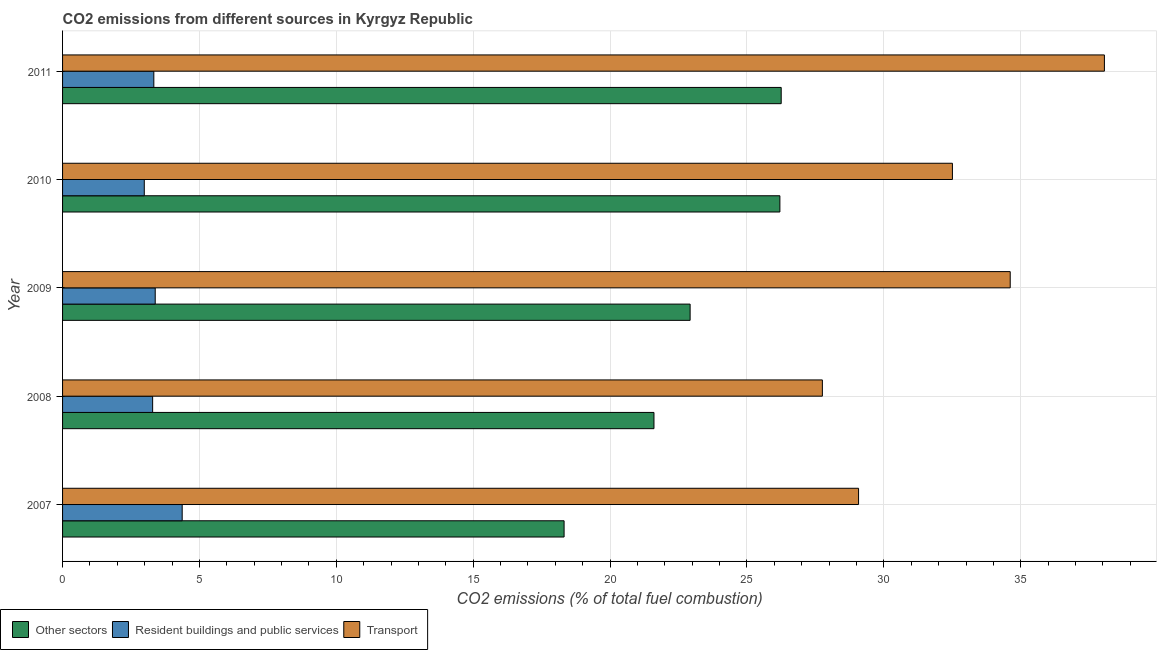Are the number of bars per tick equal to the number of legend labels?
Offer a terse response. Yes. What is the label of the 5th group of bars from the top?
Give a very brief answer. 2007. What is the percentage of co2 emissions from resident buildings and public services in 2009?
Ensure brevity in your answer.  3.38. Across all years, what is the maximum percentage of co2 emissions from transport?
Give a very brief answer. 38.06. Across all years, what is the minimum percentage of co2 emissions from other sectors?
Ensure brevity in your answer.  18.32. In which year was the percentage of co2 emissions from other sectors maximum?
Provide a succinct answer. 2011. What is the total percentage of co2 emissions from resident buildings and public services in the graph?
Provide a succinct answer. 17.36. What is the difference between the percentage of co2 emissions from resident buildings and public services in 2009 and that in 2010?
Your response must be concise. 0.4. What is the difference between the percentage of co2 emissions from other sectors in 2007 and the percentage of co2 emissions from transport in 2011?
Keep it short and to the point. -19.74. What is the average percentage of co2 emissions from transport per year?
Your response must be concise. 32.4. In the year 2007, what is the difference between the percentage of co2 emissions from transport and percentage of co2 emissions from other sectors?
Your response must be concise. 10.76. In how many years, is the percentage of co2 emissions from resident buildings and public services greater than 7 %?
Your answer should be very brief. 0. What is the ratio of the percentage of co2 emissions from resident buildings and public services in 2007 to that in 2011?
Keep it short and to the point. 1.31. Is the percentage of co2 emissions from other sectors in 2009 less than that in 2010?
Offer a terse response. Yes. What is the difference between the highest and the second highest percentage of co2 emissions from other sectors?
Offer a very short reply. 0.05. What is the difference between the highest and the lowest percentage of co2 emissions from other sectors?
Give a very brief answer. 7.93. In how many years, is the percentage of co2 emissions from resident buildings and public services greater than the average percentage of co2 emissions from resident buildings and public services taken over all years?
Offer a very short reply. 1. Is the sum of the percentage of co2 emissions from resident buildings and public services in 2007 and 2008 greater than the maximum percentage of co2 emissions from transport across all years?
Your answer should be very brief. No. What does the 1st bar from the top in 2010 represents?
Your answer should be compact. Transport. What does the 3rd bar from the bottom in 2009 represents?
Ensure brevity in your answer.  Transport. How many years are there in the graph?
Your response must be concise. 5. Are the values on the major ticks of X-axis written in scientific E-notation?
Keep it short and to the point. No. Does the graph contain any zero values?
Offer a very short reply. No. Where does the legend appear in the graph?
Provide a short and direct response. Bottom left. What is the title of the graph?
Keep it short and to the point. CO2 emissions from different sources in Kyrgyz Republic. Does "Social Protection" appear as one of the legend labels in the graph?
Provide a short and direct response. No. What is the label or title of the X-axis?
Your answer should be compact. CO2 emissions (% of total fuel combustion). What is the CO2 emissions (% of total fuel combustion) in Other sectors in 2007?
Your answer should be compact. 18.32. What is the CO2 emissions (% of total fuel combustion) in Resident buildings and public services in 2007?
Keep it short and to the point. 4.37. What is the CO2 emissions (% of total fuel combustion) of Transport in 2007?
Provide a succinct answer. 29.08. What is the CO2 emissions (% of total fuel combustion) in Other sectors in 2008?
Offer a very short reply. 21.6. What is the CO2 emissions (% of total fuel combustion) of Resident buildings and public services in 2008?
Keep it short and to the point. 3.29. What is the CO2 emissions (% of total fuel combustion) of Transport in 2008?
Your response must be concise. 27.75. What is the CO2 emissions (% of total fuel combustion) of Other sectors in 2009?
Provide a succinct answer. 22.92. What is the CO2 emissions (% of total fuel combustion) in Resident buildings and public services in 2009?
Provide a short and direct response. 3.38. What is the CO2 emissions (% of total fuel combustion) in Transport in 2009?
Your answer should be compact. 34.62. What is the CO2 emissions (% of total fuel combustion) of Other sectors in 2010?
Give a very brief answer. 26.2. What is the CO2 emissions (% of total fuel combustion) in Resident buildings and public services in 2010?
Offer a terse response. 2.99. What is the CO2 emissions (% of total fuel combustion) in Transport in 2010?
Provide a short and direct response. 32.5. What is the CO2 emissions (% of total fuel combustion) in Other sectors in 2011?
Provide a short and direct response. 26.25. What is the CO2 emissions (% of total fuel combustion) in Resident buildings and public services in 2011?
Offer a terse response. 3.33. What is the CO2 emissions (% of total fuel combustion) in Transport in 2011?
Provide a short and direct response. 38.06. Across all years, what is the maximum CO2 emissions (% of total fuel combustion) in Other sectors?
Your response must be concise. 26.25. Across all years, what is the maximum CO2 emissions (% of total fuel combustion) in Resident buildings and public services?
Keep it short and to the point. 4.37. Across all years, what is the maximum CO2 emissions (% of total fuel combustion) in Transport?
Give a very brief answer. 38.06. Across all years, what is the minimum CO2 emissions (% of total fuel combustion) in Other sectors?
Provide a succinct answer. 18.32. Across all years, what is the minimum CO2 emissions (% of total fuel combustion) of Resident buildings and public services?
Offer a terse response. 2.99. Across all years, what is the minimum CO2 emissions (% of total fuel combustion) in Transport?
Make the answer very short. 27.75. What is the total CO2 emissions (% of total fuel combustion) in Other sectors in the graph?
Your answer should be very brief. 115.3. What is the total CO2 emissions (% of total fuel combustion) of Resident buildings and public services in the graph?
Your answer should be very brief. 17.36. What is the total CO2 emissions (% of total fuel combustion) in Transport in the graph?
Ensure brevity in your answer.  162. What is the difference between the CO2 emissions (% of total fuel combustion) in Other sectors in 2007 and that in 2008?
Offer a terse response. -3.28. What is the difference between the CO2 emissions (% of total fuel combustion) of Resident buildings and public services in 2007 and that in 2008?
Your answer should be very brief. 1.08. What is the difference between the CO2 emissions (% of total fuel combustion) of Transport in 2007 and that in 2008?
Provide a short and direct response. 1.32. What is the difference between the CO2 emissions (% of total fuel combustion) in Other sectors in 2007 and that in 2009?
Your answer should be very brief. -4.6. What is the difference between the CO2 emissions (% of total fuel combustion) in Resident buildings and public services in 2007 and that in 2009?
Provide a short and direct response. 0.99. What is the difference between the CO2 emissions (% of total fuel combustion) of Transport in 2007 and that in 2009?
Your response must be concise. -5.54. What is the difference between the CO2 emissions (% of total fuel combustion) of Other sectors in 2007 and that in 2010?
Give a very brief answer. -7.88. What is the difference between the CO2 emissions (% of total fuel combustion) in Resident buildings and public services in 2007 and that in 2010?
Your answer should be compact. 1.38. What is the difference between the CO2 emissions (% of total fuel combustion) of Transport in 2007 and that in 2010?
Your answer should be compact. -3.43. What is the difference between the CO2 emissions (% of total fuel combustion) in Other sectors in 2007 and that in 2011?
Make the answer very short. -7.93. What is the difference between the CO2 emissions (% of total fuel combustion) of Resident buildings and public services in 2007 and that in 2011?
Ensure brevity in your answer.  1.04. What is the difference between the CO2 emissions (% of total fuel combustion) of Transport in 2007 and that in 2011?
Make the answer very short. -8.98. What is the difference between the CO2 emissions (% of total fuel combustion) in Other sectors in 2008 and that in 2009?
Make the answer very short. -1.32. What is the difference between the CO2 emissions (% of total fuel combustion) of Resident buildings and public services in 2008 and that in 2009?
Your answer should be compact. -0.09. What is the difference between the CO2 emissions (% of total fuel combustion) in Transport in 2008 and that in 2009?
Give a very brief answer. -6.86. What is the difference between the CO2 emissions (% of total fuel combustion) in Resident buildings and public services in 2008 and that in 2010?
Offer a terse response. 0.31. What is the difference between the CO2 emissions (% of total fuel combustion) of Transport in 2008 and that in 2010?
Your answer should be very brief. -4.75. What is the difference between the CO2 emissions (% of total fuel combustion) in Other sectors in 2008 and that in 2011?
Provide a succinct answer. -4.65. What is the difference between the CO2 emissions (% of total fuel combustion) of Resident buildings and public services in 2008 and that in 2011?
Your answer should be very brief. -0.04. What is the difference between the CO2 emissions (% of total fuel combustion) in Transport in 2008 and that in 2011?
Ensure brevity in your answer.  -10.3. What is the difference between the CO2 emissions (% of total fuel combustion) in Other sectors in 2009 and that in 2010?
Your answer should be compact. -3.28. What is the difference between the CO2 emissions (% of total fuel combustion) in Resident buildings and public services in 2009 and that in 2010?
Provide a short and direct response. 0.4. What is the difference between the CO2 emissions (% of total fuel combustion) in Transport in 2009 and that in 2010?
Make the answer very short. 2.11. What is the difference between the CO2 emissions (% of total fuel combustion) of Other sectors in 2009 and that in 2011?
Your response must be concise. -3.33. What is the difference between the CO2 emissions (% of total fuel combustion) in Resident buildings and public services in 2009 and that in 2011?
Provide a short and direct response. 0.05. What is the difference between the CO2 emissions (% of total fuel combustion) in Transport in 2009 and that in 2011?
Provide a short and direct response. -3.44. What is the difference between the CO2 emissions (% of total fuel combustion) of Other sectors in 2010 and that in 2011?
Your answer should be very brief. -0.05. What is the difference between the CO2 emissions (% of total fuel combustion) in Resident buildings and public services in 2010 and that in 2011?
Keep it short and to the point. -0.35. What is the difference between the CO2 emissions (% of total fuel combustion) of Transport in 2010 and that in 2011?
Offer a very short reply. -5.55. What is the difference between the CO2 emissions (% of total fuel combustion) of Other sectors in 2007 and the CO2 emissions (% of total fuel combustion) of Resident buildings and public services in 2008?
Keep it short and to the point. 15.03. What is the difference between the CO2 emissions (% of total fuel combustion) in Other sectors in 2007 and the CO2 emissions (% of total fuel combustion) in Transport in 2008?
Keep it short and to the point. -9.43. What is the difference between the CO2 emissions (% of total fuel combustion) of Resident buildings and public services in 2007 and the CO2 emissions (% of total fuel combustion) of Transport in 2008?
Ensure brevity in your answer.  -23.38. What is the difference between the CO2 emissions (% of total fuel combustion) of Other sectors in 2007 and the CO2 emissions (% of total fuel combustion) of Resident buildings and public services in 2009?
Give a very brief answer. 14.93. What is the difference between the CO2 emissions (% of total fuel combustion) of Other sectors in 2007 and the CO2 emissions (% of total fuel combustion) of Transport in 2009?
Provide a succinct answer. -16.3. What is the difference between the CO2 emissions (% of total fuel combustion) of Resident buildings and public services in 2007 and the CO2 emissions (% of total fuel combustion) of Transport in 2009?
Keep it short and to the point. -30.25. What is the difference between the CO2 emissions (% of total fuel combustion) in Other sectors in 2007 and the CO2 emissions (% of total fuel combustion) in Resident buildings and public services in 2010?
Give a very brief answer. 15.33. What is the difference between the CO2 emissions (% of total fuel combustion) in Other sectors in 2007 and the CO2 emissions (% of total fuel combustion) in Transport in 2010?
Your answer should be compact. -14.18. What is the difference between the CO2 emissions (% of total fuel combustion) in Resident buildings and public services in 2007 and the CO2 emissions (% of total fuel combustion) in Transport in 2010?
Offer a terse response. -28.13. What is the difference between the CO2 emissions (% of total fuel combustion) in Other sectors in 2007 and the CO2 emissions (% of total fuel combustion) in Resident buildings and public services in 2011?
Keep it short and to the point. 14.99. What is the difference between the CO2 emissions (% of total fuel combustion) in Other sectors in 2007 and the CO2 emissions (% of total fuel combustion) in Transport in 2011?
Offer a terse response. -19.74. What is the difference between the CO2 emissions (% of total fuel combustion) of Resident buildings and public services in 2007 and the CO2 emissions (% of total fuel combustion) of Transport in 2011?
Offer a terse response. -33.69. What is the difference between the CO2 emissions (% of total fuel combustion) of Other sectors in 2008 and the CO2 emissions (% of total fuel combustion) of Resident buildings and public services in 2009?
Offer a very short reply. 18.22. What is the difference between the CO2 emissions (% of total fuel combustion) in Other sectors in 2008 and the CO2 emissions (% of total fuel combustion) in Transport in 2009?
Offer a very short reply. -13.01. What is the difference between the CO2 emissions (% of total fuel combustion) in Resident buildings and public services in 2008 and the CO2 emissions (% of total fuel combustion) in Transport in 2009?
Ensure brevity in your answer.  -31.32. What is the difference between the CO2 emissions (% of total fuel combustion) in Other sectors in 2008 and the CO2 emissions (% of total fuel combustion) in Resident buildings and public services in 2010?
Your answer should be compact. 18.62. What is the difference between the CO2 emissions (% of total fuel combustion) of Other sectors in 2008 and the CO2 emissions (% of total fuel combustion) of Transport in 2010?
Your response must be concise. -10.9. What is the difference between the CO2 emissions (% of total fuel combustion) of Resident buildings and public services in 2008 and the CO2 emissions (% of total fuel combustion) of Transport in 2010?
Keep it short and to the point. -29.21. What is the difference between the CO2 emissions (% of total fuel combustion) in Other sectors in 2008 and the CO2 emissions (% of total fuel combustion) in Resident buildings and public services in 2011?
Keep it short and to the point. 18.27. What is the difference between the CO2 emissions (% of total fuel combustion) of Other sectors in 2008 and the CO2 emissions (% of total fuel combustion) of Transport in 2011?
Provide a short and direct response. -16.45. What is the difference between the CO2 emissions (% of total fuel combustion) in Resident buildings and public services in 2008 and the CO2 emissions (% of total fuel combustion) in Transport in 2011?
Provide a succinct answer. -34.77. What is the difference between the CO2 emissions (% of total fuel combustion) in Other sectors in 2009 and the CO2 emissions (% of total fuel combustion) in Resident buildings and public services in 2010?
Your response must be concise. 19.94. What is the difference between the CO2 emissions (% of total fuel combustion) in Other sectors in 2009 and the CO2 emissions (% of total fuel combustion) in Transport in 2010?
Ensure brevity in your answer.  -9.58. What is the difference between the CO2 emissions (% of total fuel combustion) of Resident buildings and public services in 2009 and the CO2 emissions (% of total fuel combustion) of Transport in 2010?
Provide a short and direct response. -29.12. What is the difference between the CO2 emissions (% of total fuel combustion) in Other sectors in 2009 and the CO2 emissions (% of total fuel combustion) in Resident buildings and public services in 2011?
Your response must be concise. 19.59. What is the difference between the CO2 emissions (% of total fuel combustion) in Other sectors in 2009 and the CO2 emissions (% of total fuel combustion) in Transport in 2011?
Provide a short and direct response. -15.13. What is the difference between the CO2 emissions (% of total fuel combustion) in Resident buildings and public services in 2009 and the CO2 emissions (% of total fuel combustion) in Transport in 2011?
Provide a succinct answer. -34.67. What is the difference between the CO2 emissions (% of total fuel combustion) of Other sectors in 2010 and the CO2 emissions (% of total fuel combustion) of Resident buildings and public services in 2011?
Your response must be concise. 22.87. What is the difference between the CO2 emissions (% of total fuel combustion) in Other sectors in 2010 and the CO2 emissions (% of total fuel combustion) in Transport in 2011?
Your answer should be very brief. -11.85. What is the difference between the CO2 emissions (% of total fuel combustion) of Resident buildings and public services in 2010 and the CO2 emissions (% of total fuel combustion) of Transport in 2011?
Make the answer very short. -35.07. What is the average CO2 emissions (% of total fuel combustion) of Other sectors per year?
Make the answer very short. 23.06. What is the average CO2 emissions (% of total fuel combustion) of Resident buildings and public services per year?
Offer a terse response. 3.47. What is the average CO2 emissions (% of total fuel combustion) in Transport per year?
Ensure brevity in your answer.  32.4. In the year 2007, what is the difference between the CO2 emissions (% of total fuel combustion) of Other sectors and CO2 emissions (% of total fuel combustion) of Resident buildings and public services?
Provide a short and direct response. 13.95. In the year 2007, what is the difference between the CO2 emissions (% of total fuel combustion) in Other sectors and CO2 emissions (% of total fuel combustion) in Transport?
Provide a succinct answer. -10.76. In the year 2007, what is the difference between the CO2 emissions (% of total fuel combustion) of Resident buildings and public services and CO2 emissions (% of total fuel combustion) of Transport?
Keep it short and to the point. -24.71. In the year 2008, what is the difference between the CO2 emissions (% of total fuel combustion) in Other sectors and CO2 emissions (% of total fuel combustion) in Resident buildings and public services?
Your answer should be very brief. 18.31. In the year 2008, what is the difference between the CO2 emissions (% of total fuel combustion) of Other sectors and CO2 emissions (% of total fuel combustion) of Transport?
Ensure brevity in your answer.  -6.15. In the year 2008, what is the difference between the CO2 emissions (% of total fuel combustion) in Resident buildings and public services and CO2 emissions (% of total fuel combustion) in Transport?
Give a very brief answer. -24.46. In the year 2009, what is the difference between the CO2 emissions (% of total fuel combustion) of Other sectors and CO2 emissions (% of total fuel combustion) of Resident buildings and public services?
Offer a terse response. 19.54. In the year 2009, what is the difference between the CO2 emissions (% of total fuel combustion) in Other sectors and CO2 emissions (% of total fuel combustion) in Transport?
Give a very brief answer. -11.69. In the year 2009, what is the difference between the CO2 emissions (% of total fuel combustion) of Resident buildings and public services and CO2 emissions (% of total fuel combustion) of Transport?
Give a very brief answer. -31.23. In the year 2010, what is the difference between the CO2 emissions (% of total fuel combustion) of Other sectors and CO2 emissions (% of total fuel combustion) of Resident buildings and public services?
Offer a very short reply. 23.22. In the year 2010, what is the difference between the CO2 emissions (% of total fuel combustion) of Other sectors and CO2 emissions (% of total fuel combustion) of Transport?
Offer a terse response. -6.3. In the year 2010, what is the difference between the CO2 emissions (% of total fuel combustion) of Resident buildings and public services and CO2 emissions (% of total fuel combustion) of Transport?
Your response must be concise. -29.52. In the year 2011, what is the difference between the CO2 emissions (% of total fuel combustion) of Other sectors and CO2 emissions (% of total fuel combustion) of Resident buildings and public services?
Give a very brief answer. 22.92. In the year 2011, what is the difference between the CO2 emissions (% of total fuel combustion) of Other sectors and CO2 emissions (% of total fuel combustion) of Transport?
Your response must be concise. -11.81. In the year 2011, what is the difference between the CO2 emissions (% of total fuel combustion) of Resident buildings and public services and CO2 emissions (% of total fuel combustion) of Transport?
Your answer should be compact. -34.72. What is the ratio of the CO2 emissions (% of total fuel combustion) in Other sectors in 2007 to that in 2008?
Offer a terse response. 0.85. What is the ratio of the CO2 emissions (% of total fuel combustion) of Resident buildings and public services in 2007 to that in 2008?
Give a very brief answer. 1.33. What is the ratio of the CO2 emissions (% of total fuel combustion) in Transport in 2007 to that in 2008?
Give a very brief answer. 1.05. What is the ratio of the CO2 emissions (% of total fuel combustion) in Other sectors in 2007 to that in 2009?
Your answer should be very brief. 0.8. What is the ratio of the CO2 emissions (% of total fuel combustion) of Resident buildings and public services in 2007 to that in 2009?
Keep it short and to the point. 1.29. What is the ratio of the CO2 emissions (% of total fuel combustion) of Transport in 2007 to that in 2009?
Your response must be concise. 0.84. What is the ratio of the CO2 emissions (% of total fuel combustion) in Other sectors in 2007 to that in 2010?
Keep it short and to the point. 0.7. What is the ratio of the CO2 emissions (% of total fuel combustion) of Resident buildings and public services in 2007 to that in 2010?
Your answer should be compact. 1.46. What is the ratio of the CO2 emissions (% of total fuel combustion) of Transport in 2007 to that in 2010?
Your response must be concise. 0.89. What is the ratio of the CO2 emissions (% of total fuel combustion) of Other sectors in 2007 to that in 2011?
Your answer should be compact. 0.7. What is the ratio of the CO2 emissions (% of total fuel combustion) in Resident buildings and public services in 2007 to that in 2011?
Ensure brevity in your answer.  1.31. What is the ratio of the CO2 emissions (% of total fuel combustion) in Transport in 2007 to that in 2011?
Ensure brevity in your answer.  0.76. What is the ratio of the CO2 emissions (% of total fuel combustion) of Other sectors in 2008 to that in 2009?
Keep it short and to the point. 0.94. What is the ratio of the CO2 emissions (% of total fuel combustion) of Resident buildings and public services in 2008 to that in 2009?
Provide a short and direct response. 0.97. What is the ratio of the CO2 emissions (% of total fuel combustion) of Transport in 2008 to that in 2009?
Provide a succinct answer. 0.8. What is the ratio of the CO2 emissions (% of total fuel combustion) in Other sectors in 2008 to that in 2010?
Your answer should be very brief. 0.82. What is the ratio of the CO2 emissions (% of total fuel combustion) of Resident buildings and public services in 2008 to that in 2010?
Provide a succinct answer. 1.1. What is the ratio of the CO2 emissions (% of total fuel combustion) of Transport in 2008 to that in 2010?
Keep it short and to the point. 0.85. What is the ratio of the CO2 emissions (% of total fuel combustion) of Other sectors in 2008 to that in 2011?
Make the answer very short. 0.82. What is the ratio of the CO2 emissions (% of total fuel combustion) of Resident buildings and public services in 2008 to that in 2011?
Offer a terse response. 0.99. What is the ratio of the CO2 emissions (% of total fuel combustion) in Transport in 2008 to that in 2011?
Make the answer very short. 0.73. What is the ratio of the CO2 emissions (% of total fuel combustion) in Other sectors in 2009 to that in 2010?
Keep it short and to the point. 0.87. What is the ratio of the CO2 emissions (% of total fuel combustion) in Resident buildings and public services in 2009 to that in 2010?
Offer a terse response. 1.13. What is the ratio of the CO2 emissions (% of total fuel combustion) in Transport in 2009 to that in 2010?
Offer a terse response. 1.06. What is the ratio of the CO2 emissions (% of total fuel combustion) of Other sectors in 2009 to that in 2011?
Ensure brevity in your answer.  0.87. What is the ratio of the CO2 emissions (% of total fuel combustion) in Resident buildings and public services in 2009 to that in 2011?
Provide a succinct answer. 1.02. What is the ratio of the CO2 emissions (% of total fuel combustion) in Transport in 2009 to that in 2011?
Make the answer very short. 0.91. What is the ratio of the CO2 emissions (% of total fuel combustion) in Other sectors in 2010 to that in 2011?
Keep it short and to the point. 1. What is the ratio of the CO2 emissions (% of total fuel combustion) in Resident buildings and public services in 2010 to that in 2011?
Offer a terse response. 0.9. What is the ratio of the CO2 emissions (% of total fuel combustion) in Transport in 2010 to that in 2011?
Your response must be concise. 0.85. What is the difference between the highest and the second highest CO2 emissions (% of total fuel combustion) in Other sectors?
Provide a succinct answer. 0.05. What is the difference between the highest and the second highest CO2 emissions (% of total fuel combustion) of Resident buildings and public services?
Provide a short and direct response. 0.99. What is the difference between the highest and the second highest CO2 emissions (% of total fuel combustion) in Transport?
Keep it short and to the point. 3.44. What is the difference between the highest and the lowest CO2 emissions (% of total fuel combustion) of Other sectors?
Ensure brevity in your answer.  7.93. What is the difference between the highest and the lowest CO2 emissions (% of total fuel combustion) in Resident buildings and public services?
Provide a succinct answer. 1.38. What is the difference between the highest and the lowest CO2 emissions (% of total fuel combustion) in Transport?
Your response must be concise. 10.3. 